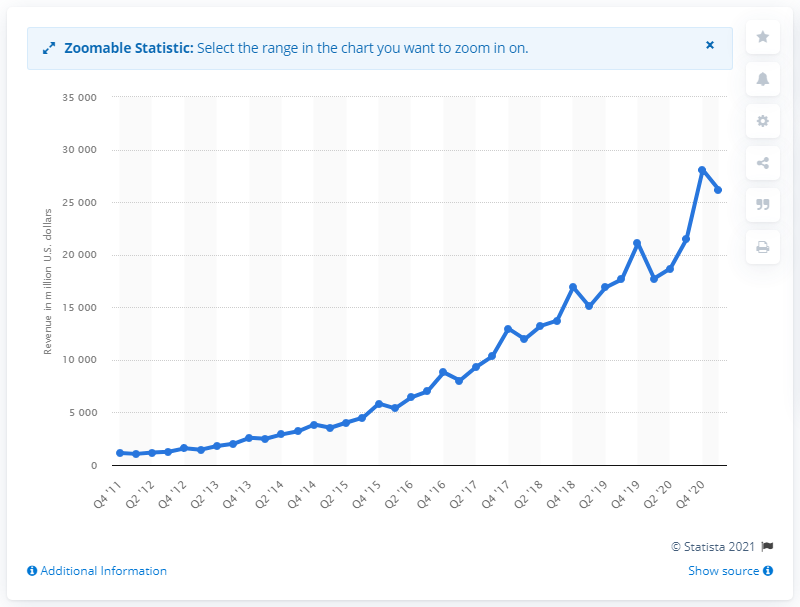Give some essential details in this illustration. Facebook's total revenue for the first quarter of 2021 was 26,171. 